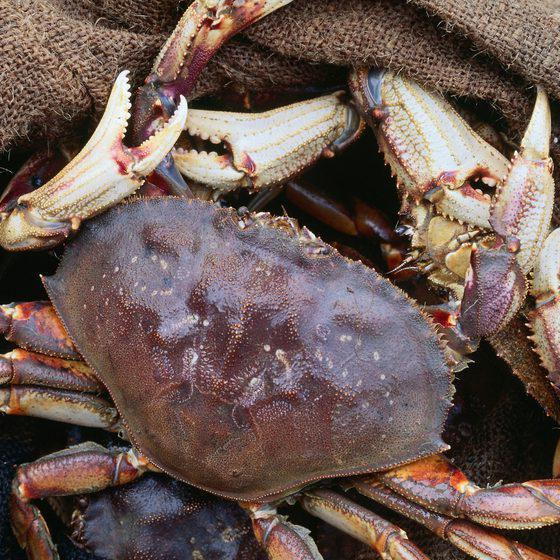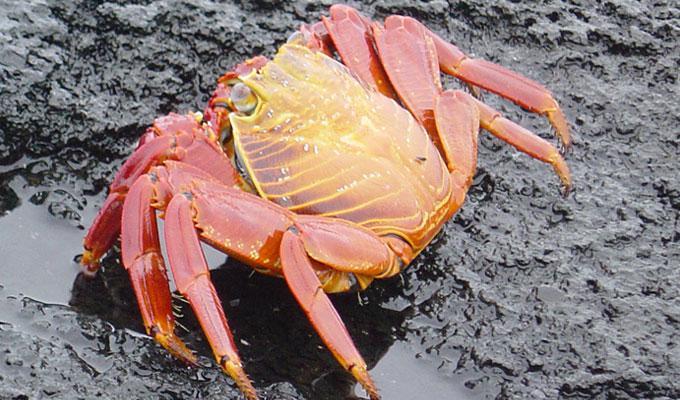The first image is the image on the left, the second image is the image on the right. For the images shown, is this caption "Eight or fewer crabs are visible." true? Answer yes or no. Yes. The first image is the image on the left, the second image is the image on the right. Given the left and right images, does the statement "The right image contains one animal." hold true? Answer yes or no. Yes. 